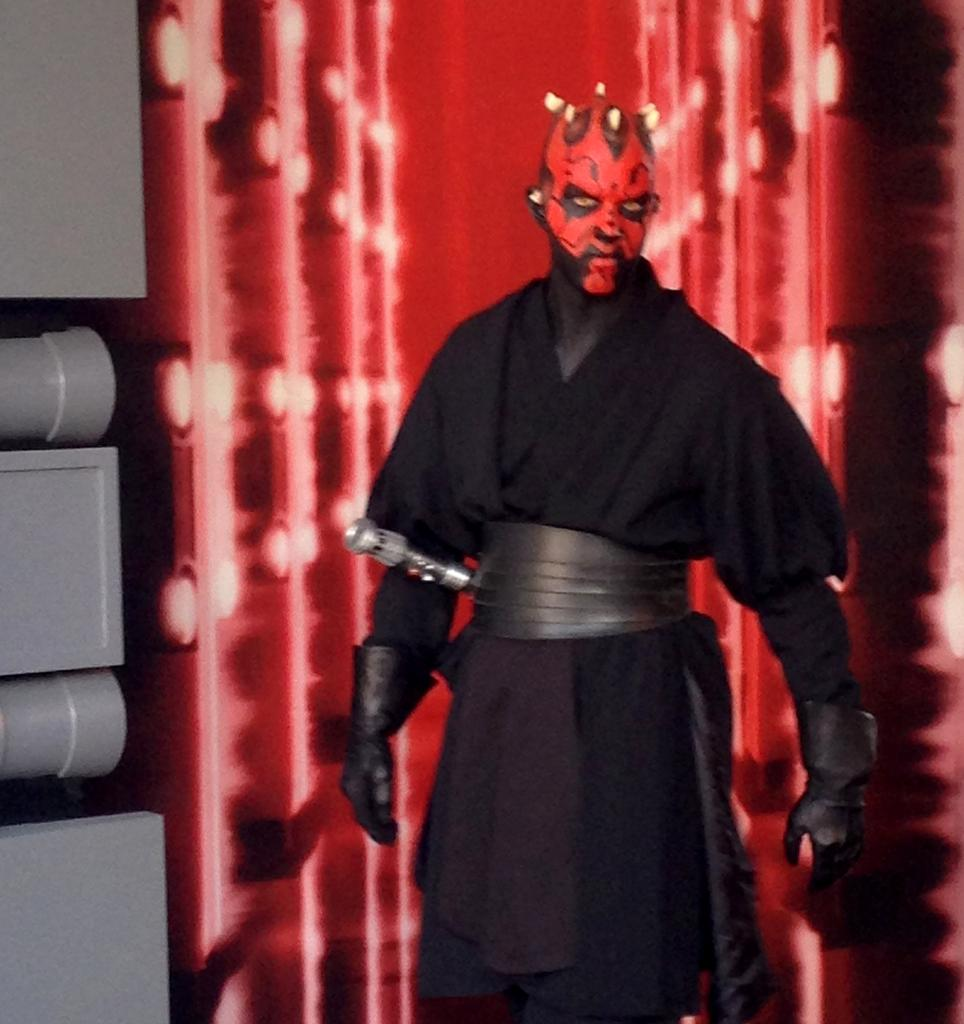What is present in the image? There is a person in the image. What is the person wearing? The person is wearing a costume. What can be seen in the background of the image? There is light visible in the background of the image. What type of advice can be heard from the person in the image? There is no indication in the image that the person is giving advice, so it cannot be determined from the picture. What country is the person in the image from? There is no information about the person's country of origin in the image. What type of cake is being served in the image? There is no cake present in the image. 